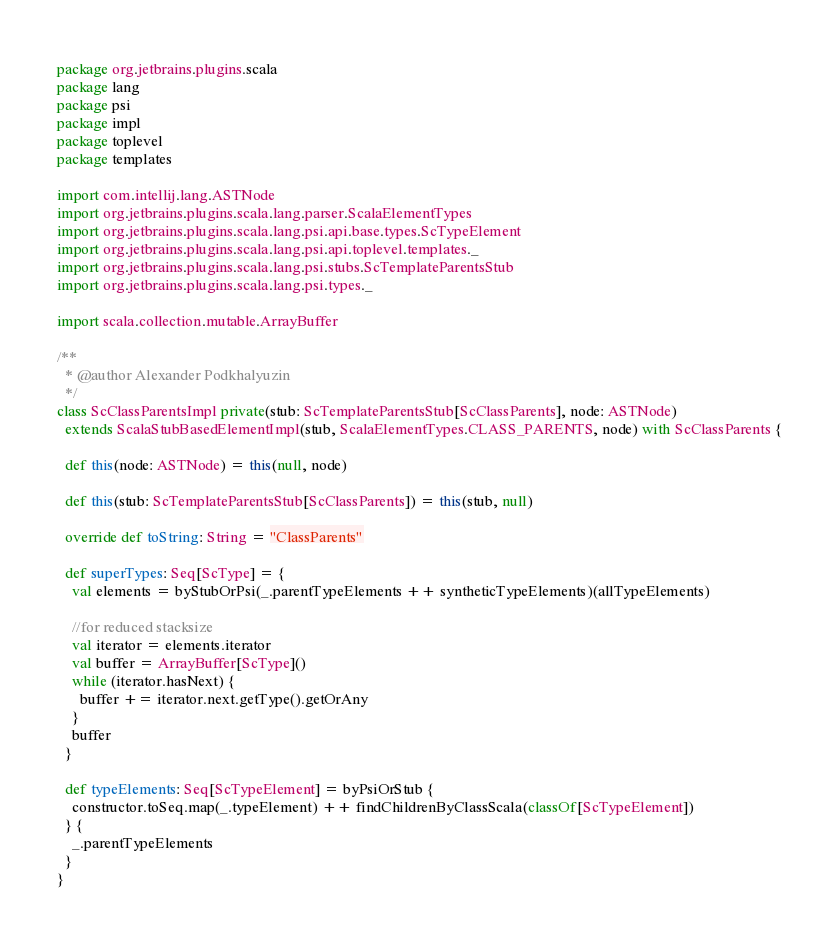<code> <loc_0><loc_0><loc_500><loc_500><_Scala_>package org.jetbrains.plugins.scala
package lang
package psi
package impl
package toplevel
package templates

import com.intellij.lang.ASTNode
import org.jetbrains.plugins.scala.lang.parser.ScalaElementTypes
import org.jetbrains.plugins.scala.lang.psi.api.base.types.ScTypeElement
import org.jetbrains.plugins.scala.lang.psi.api.toplevel.templates._
import org.jetbrains.plugins.scala.lang.psi.stubs.ScTemplateParentsStub
import org.jetbrains.plugins.scala.lang.psi.types._

import scala.collection.mutable.ArrayBuffer

/**
  * @author Alexander Podkhalyuzin
  */
class ScClassParentsImpl private(stub: ScTemplateParentsStub[ScClassParents], node: ASTNode)
  extends ScalaStubBasedElementImpl(stub, ScalaElementTypes.CLASS_PARENTS, node) with ScClassParents {

  def this(node: ASTNode) = this(null, node)

  def this(stub: ScTemplateParentsStub[ScClassParents]) = this(stub, null)

  override def toString: String = "ClassParents"

  def superTypes: Seq[ScType] = {
    val elements = byStubOrPsi(_.parentTypeElements ++ syntheticTypeElements)(allTypeElements)

    //for reduced stacksize
    val iterator = elements.iterator
    val buffer = ArrayBuffer[ScType]()
    while (iterator.hasNext) {
      buffer += iterator.next.getType().getOrAny
    }
    buffer
  }

  def typeElements: Seq[ScTypeElement] = byPsiOrStub {
    constructor.toSeq.map(_.typeElement) ++ findChildrenByClassScala(classOf[ScTypeElement])
  } {
    _.parentTypeElements
  }
}</code> 